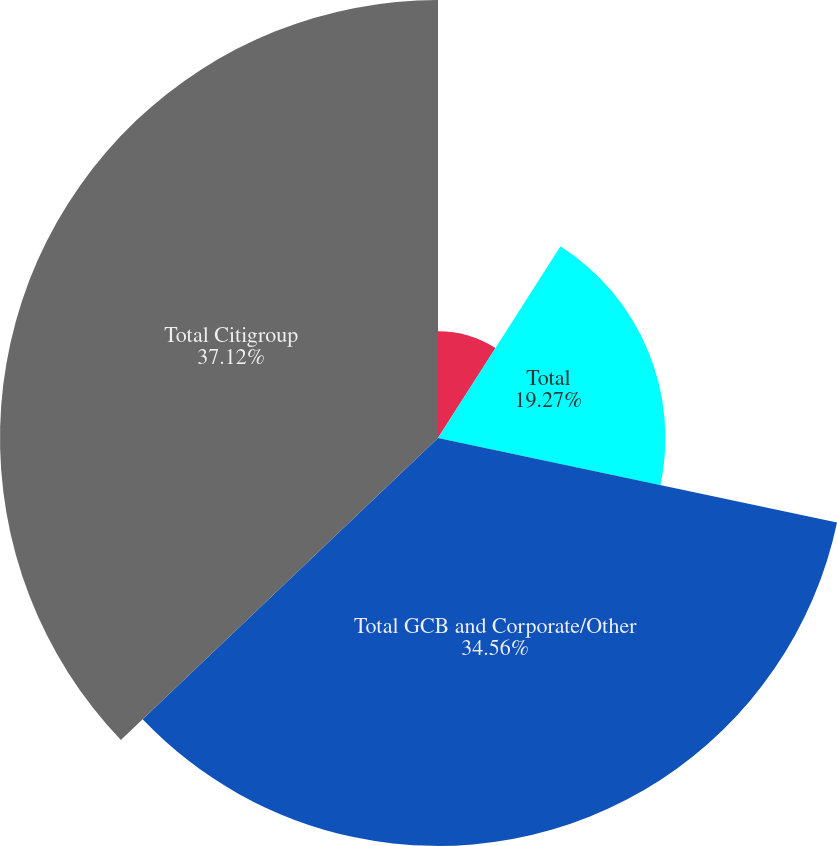Convert chart to OTSL. <chart><loc_0><loc_0><loc_500><loc_500><pie_chart><fcel>Residential first mortgages<fcel>Total<fcel>Total GCB and Corporate/Other<fcel>Total Citigroup<nl><fcel>9.05%<fcel>19.27%<fcel>34.56%<fcel>37.11%<nl></chart> 